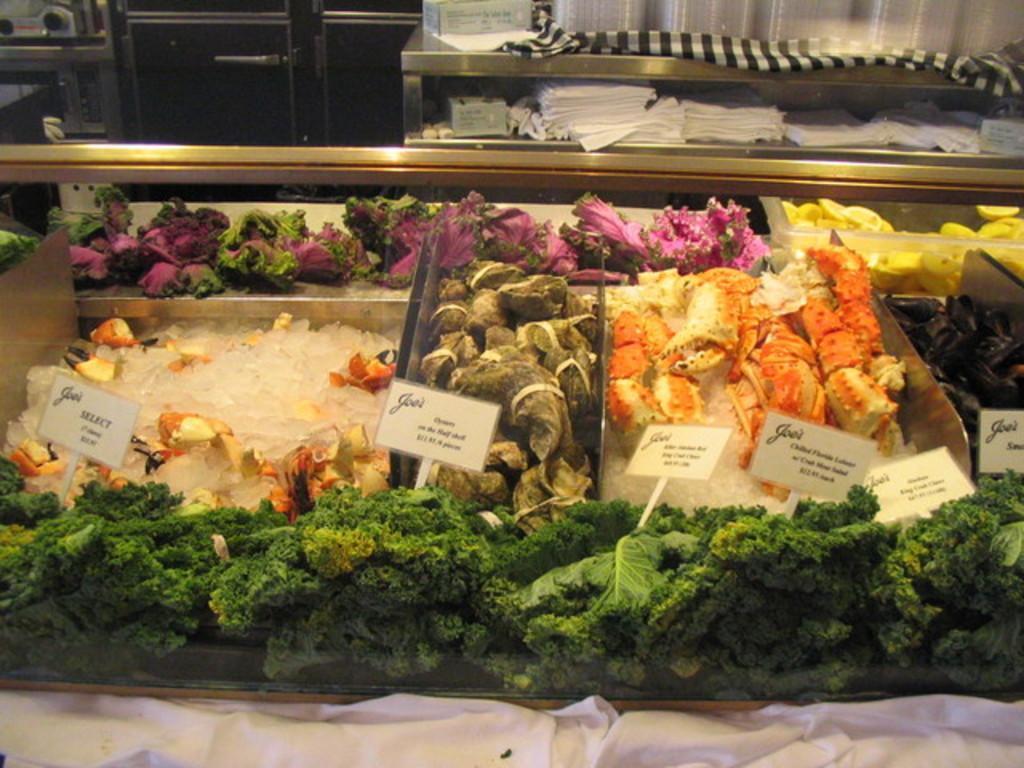Can you describe this image briefly? In this image I can see different types of food, few white colour boards, number of ice cubes and on these boards I can see something is written. On the top side of the image I can see a cloth, few plastic things, number of tissue papers and few other stuffs. On the top left side of the image I can see few black colour things. 